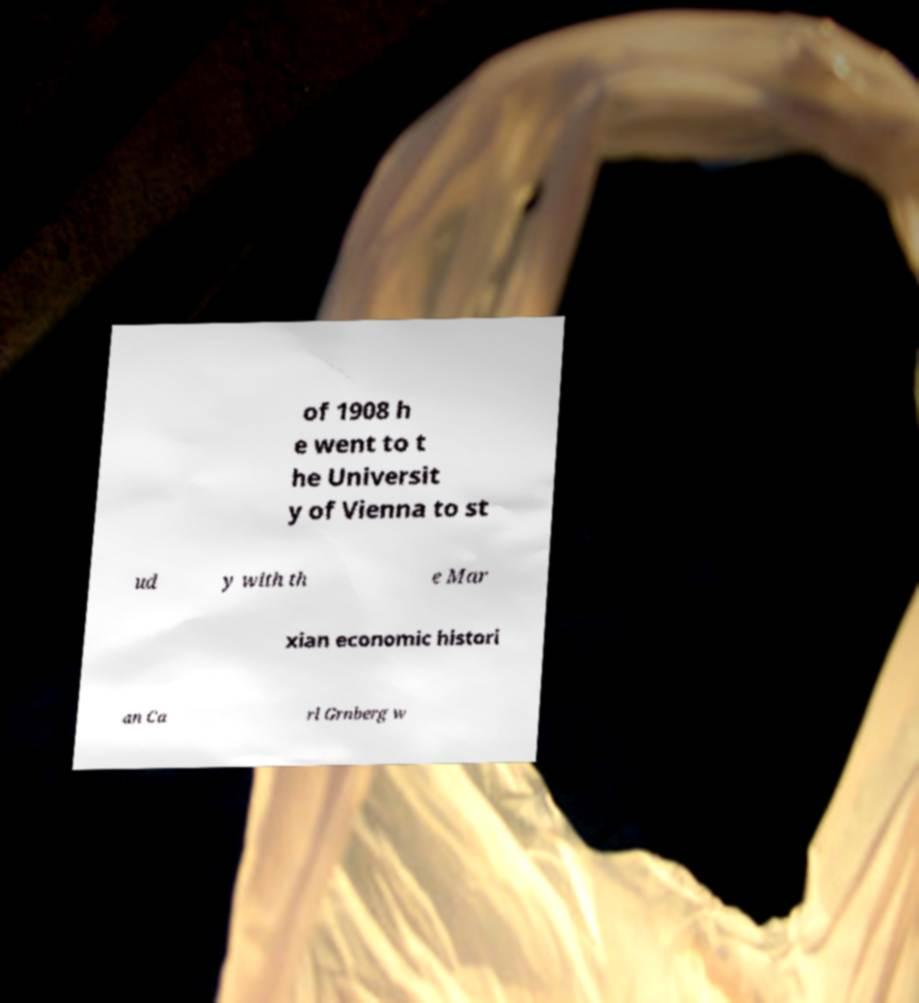Could you extract and type out the text from this image? of 1908 h e went to t he Universit y of Vienna to st ud y with th e Mar xian economic histori an Ca rl Grnberg w 